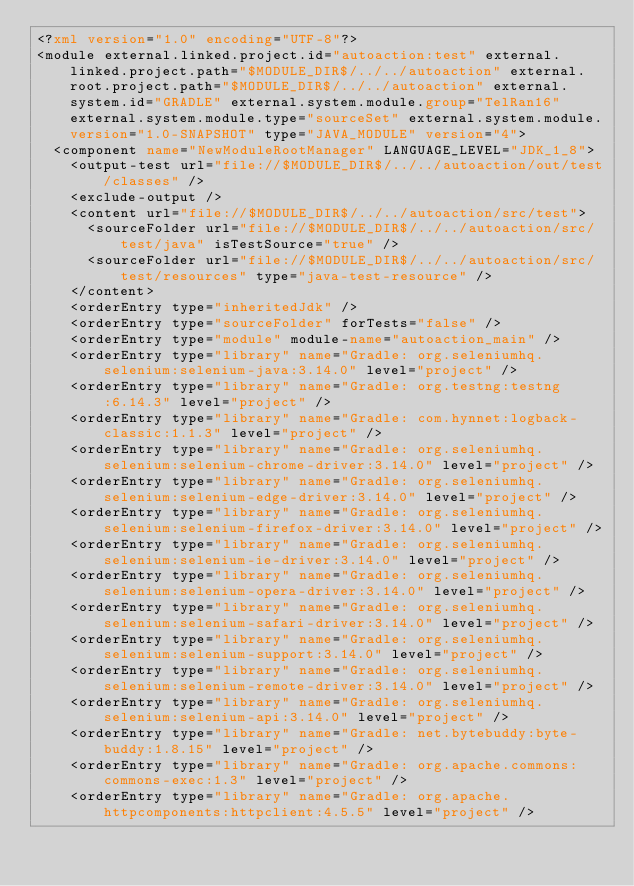Convert code to text. <code><loc_0><loc_0><loc_500><loc_500><_XML_><?xml version="1.0" encoding="UTF-8"?>
<module external.linked.project.id="autoaction:test" external.linked.project.path="$MODULE_DIR$/../../autoaction" external.root.project.path="$MODULE_DIR$/../../autoaction" external.system.id="GRADLE" external.system.module.group="TelRan16" external.system.module.type="sourceSet" external.system.module.version="1.0-SNAPSHOT" type="JAVA_MODULE" version="4">
  <component name="NewModuleRootManager" LANGUAGE_LEVEL="JDK_1_8">
    <output-test url="file://$MODULE_DIR$/../../autoaction/out/test/classes" />
    <exclude-output />
    <content url="file://$MODULE_DIR$/../../autoaction/src/test">
      <sourceFolder url="file://$MODULE_DIR$/../../autoaction/src/test/java" isTestSource="true" />
      <sourceFolder url="file://$MODULE_DIR$/../../autoaction/src/test/resources" type="java-test-resource" />
    </content>
    <orderEntry type="inheritedJdk" />
    <orderEntry type="sourceFolder" forTests="false" />
    <orderEntry type="module" module-name="autoaction_main" />
    <orderEntry type="library" name="Gradle: org.seleniumhq.selenium:selenium-java:3.14.0" level="project" />
    <orderEntry type="library" name="Gradle: org.testng:testng:6.14.3" level="project" />
    <orderEntry type="library" name="Gradle: com.hynnet:logback-classic:1.1.3" level="project" />
    <orderEntry type="library" name="Gradle: org.seleniumhq.selenium:selenium-chrome-driver:3.14.0" level="project" />
    <orderEntry type="library" name="Gradle: org.seleniumhq.selenium:selenium-edge-driver:3.14.0" level="project" />
    <orderEntry type="library" name="Gradle: org.seleniumhq.selenium:selenium-firefox-driver:3.14.0" level="project" />
    <orderEntry type="library" name="Gradle: org.seleniumhq.selenium:selenium-ie-driver:3.14.0" level="project" />
    <orderEntry type="library" name="Gradle: org.seleniumhq.selenium:selenium-opera-driver:3.14.0" level="project" />
    <orderEntry type="library" name="Gradle: org.seleniumhq.selenium:selenium-safari-driver:3.14.0" level="project" />
    <orderEntry type="library" name="Gradle: org.seleniumhq.selenium:selenium-support:3.14.0" level="project" />
    <orderEntry type="library" name="Gradle: org.seleniumhq.selenium:selenium-remote-driver:3.14.0" level="project" />
    <orderEntry type="library" name="Gradle: org.seleniumhq.selenium:selenium-api:3.14.0" level="project" />
    <orderEntry type="library" name="Gradle: net.bytebuddy:byte-buddy:1.8.15" level="project" />
    <orderEntry type="library" name="Gradle: org.apache.commons:commons-exec:1.3" level="project" />
    <orderEntry type="library" name="Gradle: org.apache.httpcomponents:httpclient:4.5.5" level="project" /></code> 